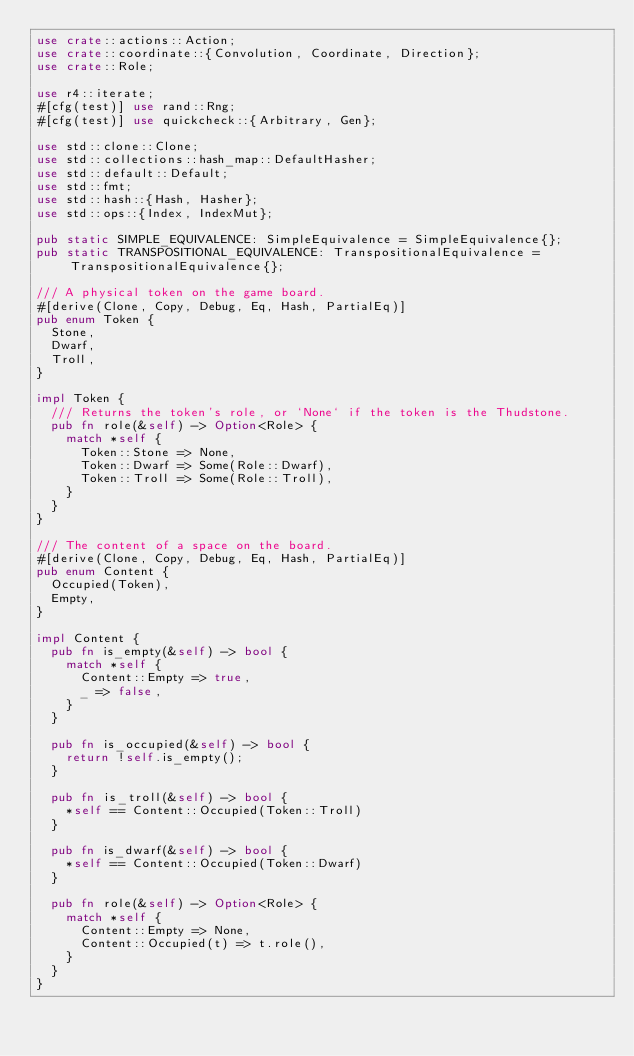Convert code to text. <code><loc_0><loc_0><loc_500><loc_500><_Rust_>use crate::actions::Action;
use crate::coordinate::{Convolution, Coordinate, Direction};
use crate::Role;

use r4::iterate;
#[cfg(test)] use rand::Rng;
#[cfg(test)] use quickcheck::{Arbitrary, Gen};

use std::clone::Clone;
use std::collections::hash_map::DefaultHasher;
use std::default::Default;
use std::fmt;
use std::hash::{Hash, Hasher};
use std::ops::{Index, IndexMut};

pub static SIMPLE_EQUIVALENCE: SimpleEquivalence = SimpleEquivalence{};
pub static TRANSPOSITIONAL_EQUIVALENCE: TranspositionalEquivalence = TranspositionalEquivalence{};

/// A physical token on the game board.
#[derive(Clone, Copy, Debug, Eq, Hash, PartialEq)]
pub enum Token {
  Stone,
  Dwarf,
  Troll,
}

impl Token {
  /// Returns the token's role, or `None` if the token is the Thudstone.
  pub fn role(&self) -> Option<Role> {
    match *self {
      Token::Stone => None,
      Token::Dwarf => Some(Role::Dwarf),
      Token::Troll => Some(Role::Troll),
    }
  }
}

/// The content of a space on the board.
#[derive(Clone, Copy, Debug, Eq, Hash, PartialEq)]
pub enum Content {
  Occupied(Token),
  Empty,
}

impl Content {
  pub fn is_empty(&self) -> bool {
    match *self {
      Content::Empty => true,
      _ => false,
    }
  }

  pub fn is_occupied(&self) -> bool {
    return !self.is_empty();
  }

  pub fn is_troll(&self) -> bool {
    *self == Content::Occupied(Token::Troll)
  }

  pub fn is_dwarf(&self) -> bool {
    *self == Content::Occupied(Token::Dwarf)
  }

  pub fn role(&self) -> Option<Role> {
    match *self {
      Content::Empty => None,
      Content::Occupied(t) => t.role(),
    }
  }
}
</code> 